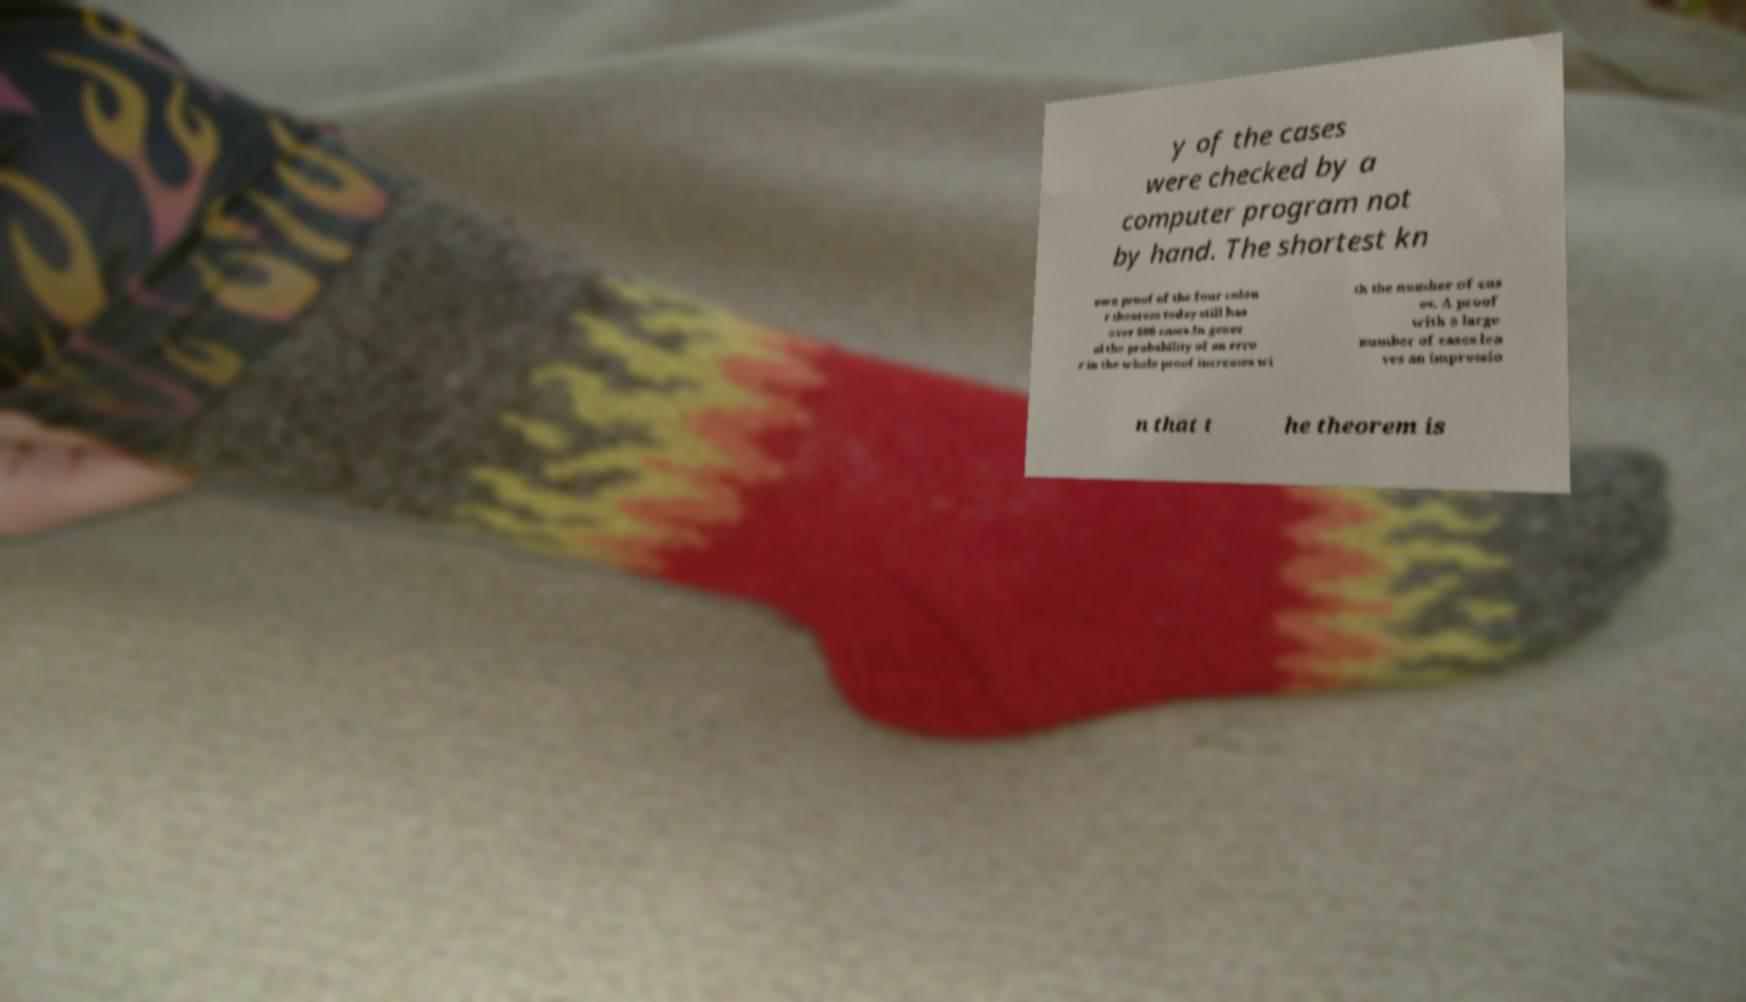Can you accurately transcribe the text from the provided image for me? y of the cases were checked by a computer program not by hand. The shortest kn own proof of the four colou r theorem today still has over 600 cases.In gener al the probability of an erro r in the whole proof increases wi th the number of cas es. A proof with a large number of cases lea ves an impressio n that t he theorem is 